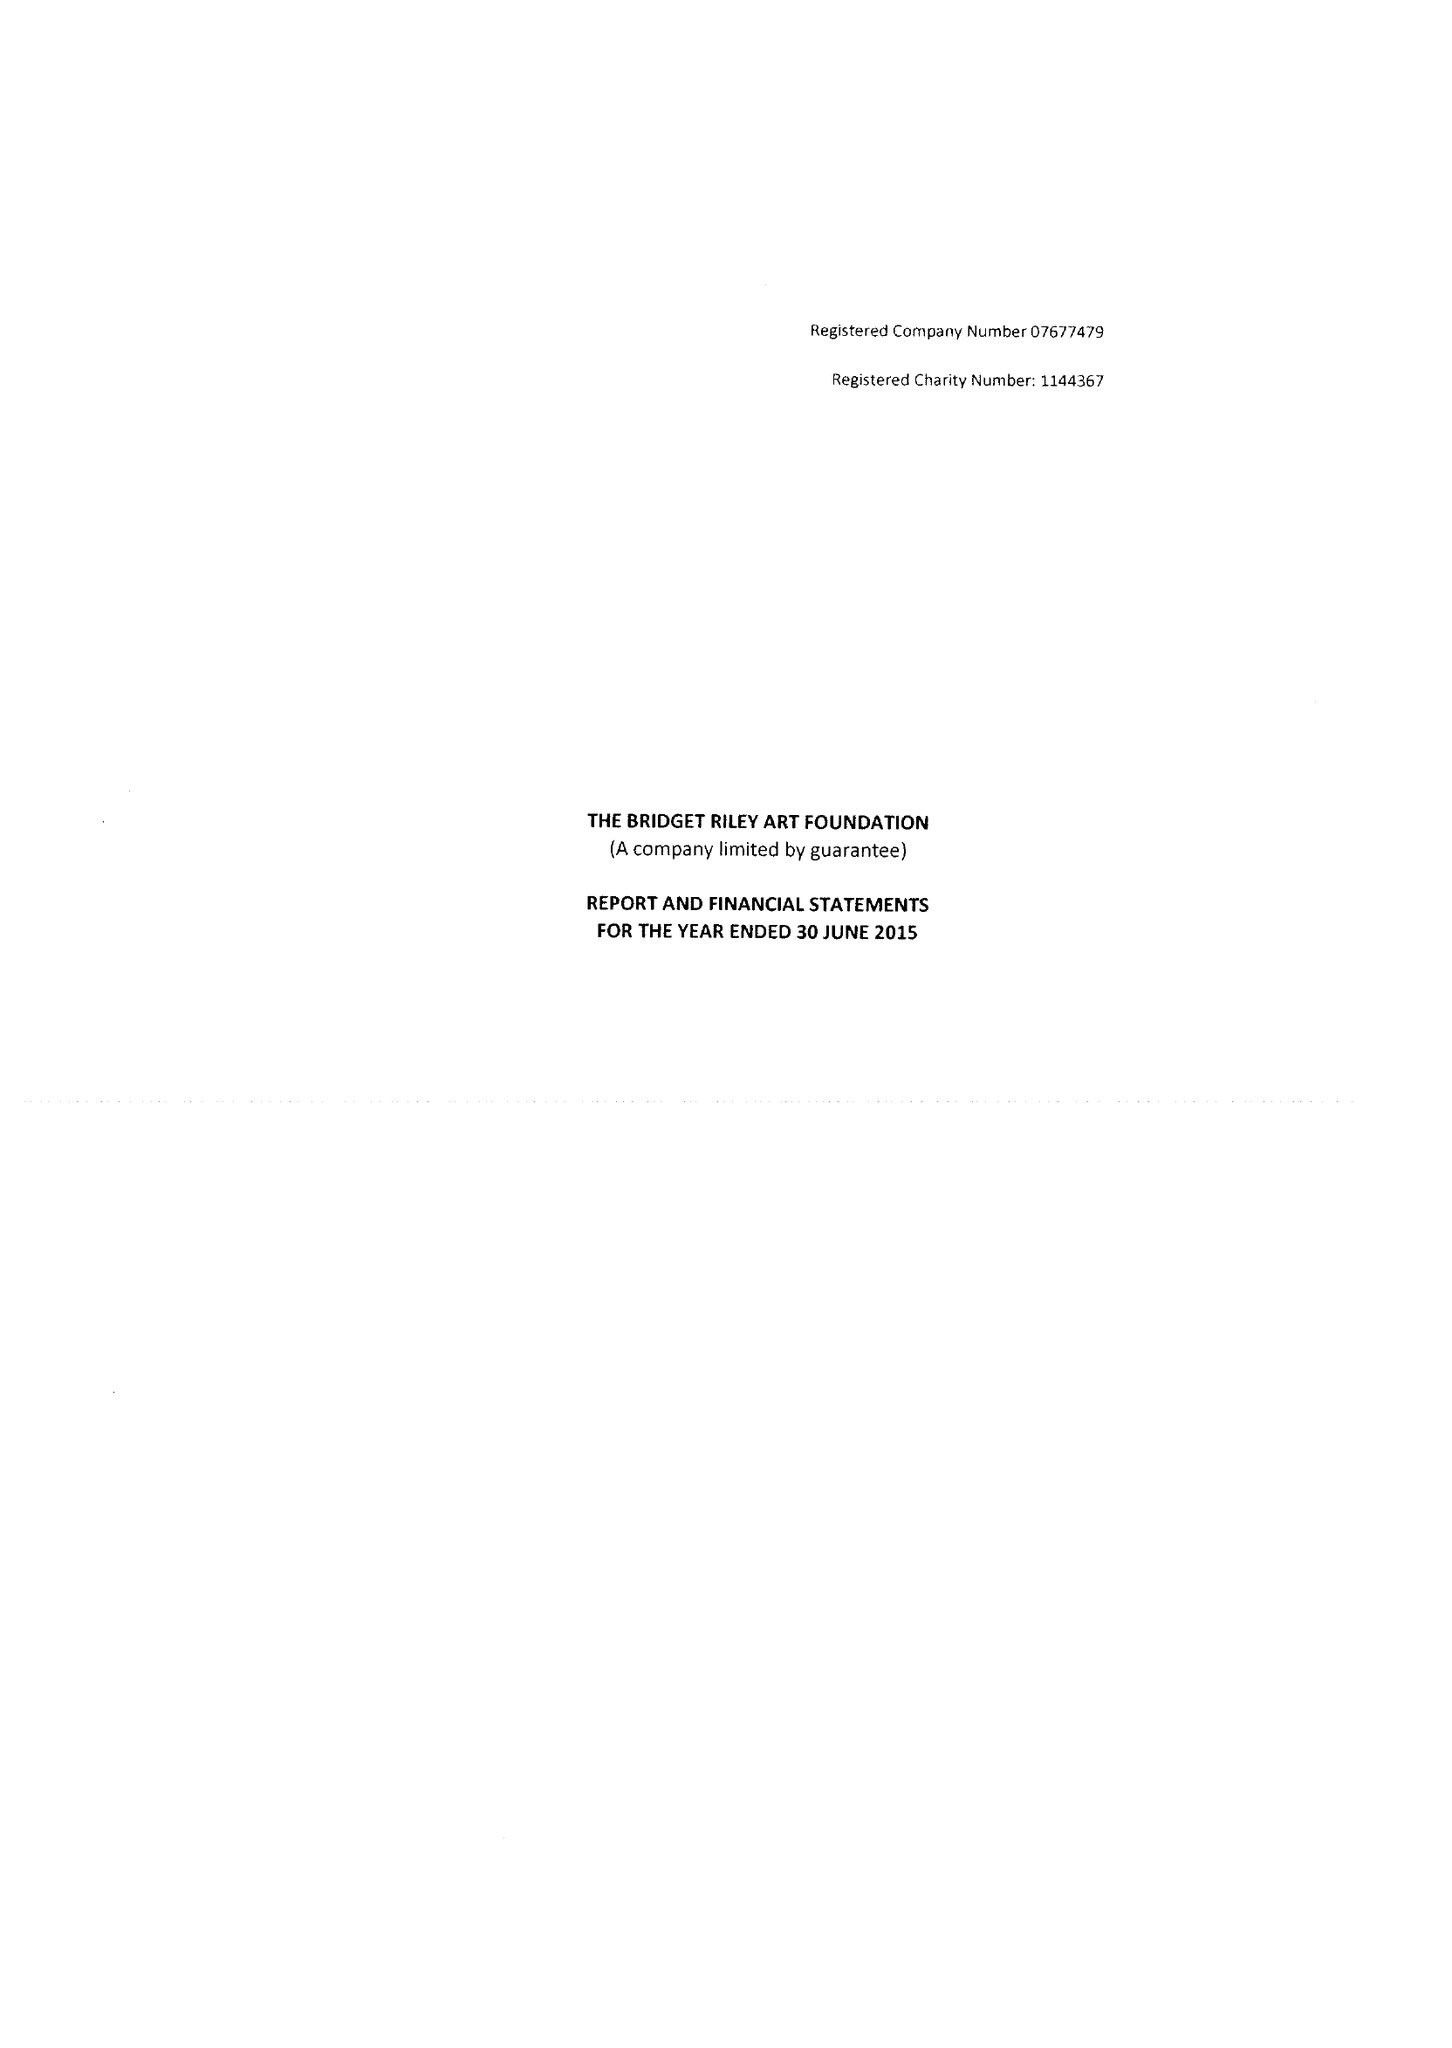What is the value for the spending_annually_in_british_pounds?
Answer the question using a single word or phrase. 89855.00 